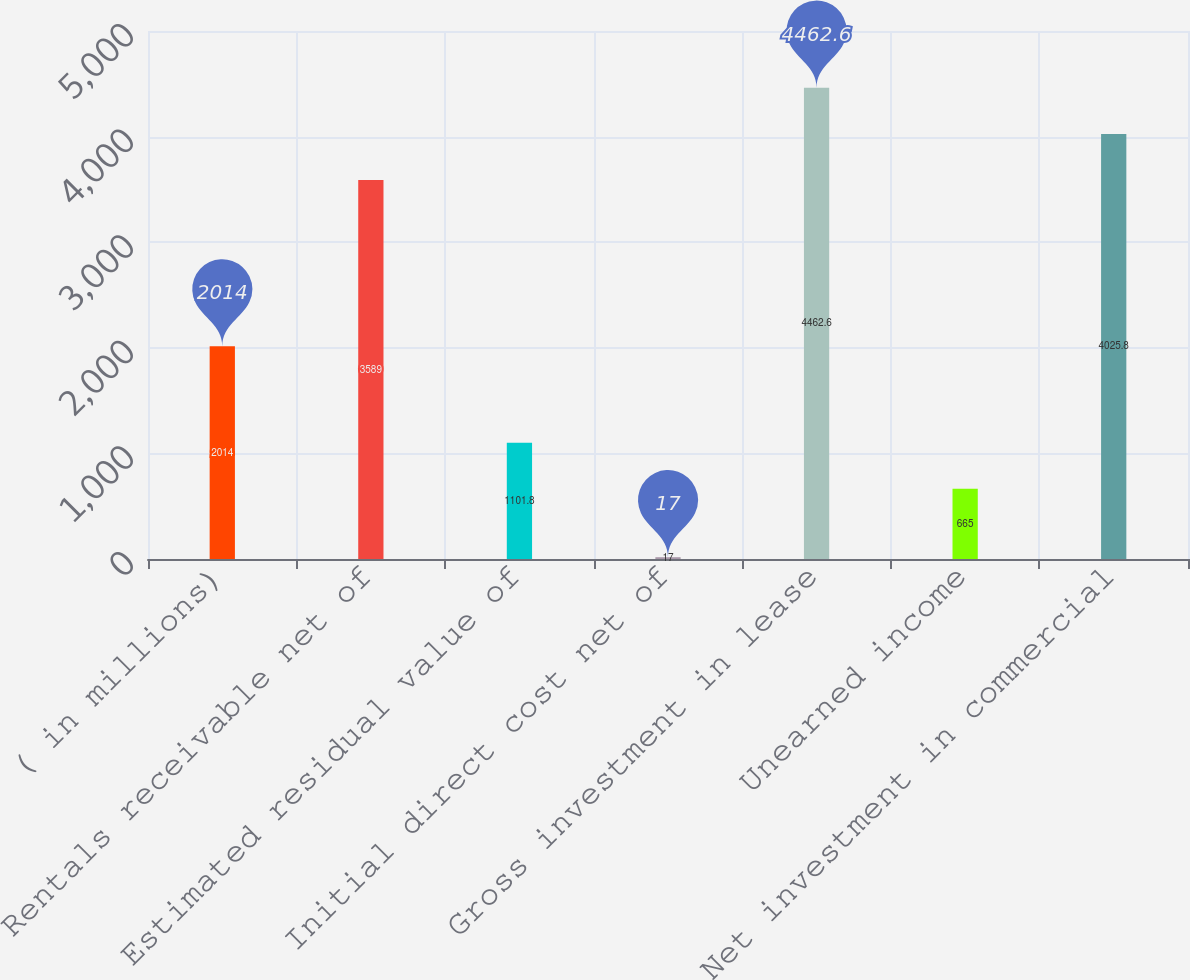Convert chart to OTSL. <chart><loc_0><loc_0><loc_500><loc_500><bar_chart><fcel>( in millions)<fcel>Rentals receivable net of<fcel>Estimated residual value of<fcel>Initial direct cost net of<fcel>Gross investment in lease<fcel>Unearned income<fcel>Net investment in commercial<nl><fcel>2014<fcel>3589<fcel>1101.8<fcel>17<fcel>4462.6<fcel>665<fcel>4025.8<nl></chart> 